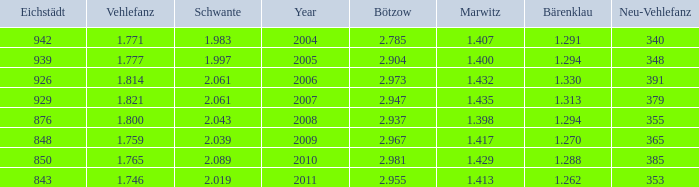What year has a Schwante smaller than 2.043, an Eichstädt smaller than 848, and a Bärenklau smaller than 1.262? 0.0. 